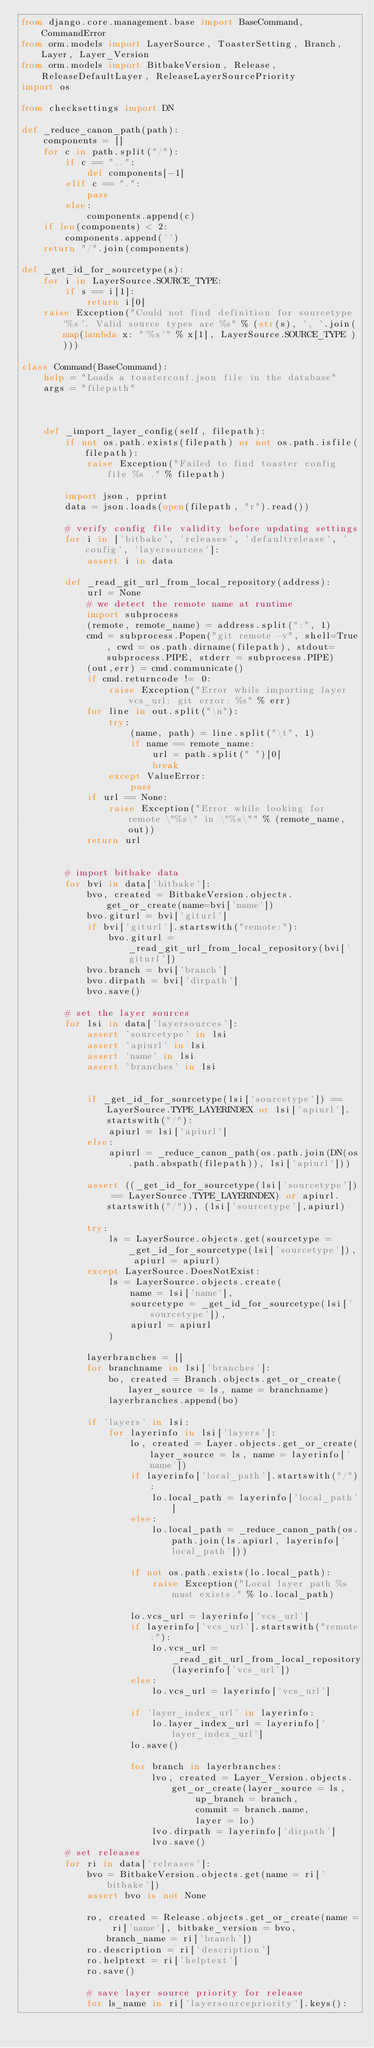Convert code to text. <code><loc_0><loc_0><loc_500><loc_500><_Python_>from django.core.management.base import BaseCommand, CommandError
from orm.models import LayerSource, ToasterSetting, Branch, Layer, Layer_Version
from orm.models import BitbakeVersion, Release, ReleaseDefaultLayer, ReleaseLayerSourcePriority
import os

from checksettings import DN

def _reduce_canon_path(path):
    components = []
    for c in path.split("/"):
        if c == "..":
            del components[-1]
        elif c == ".":
            pass
        else:
            components.append(c)
    if len(components) < 2:
        components.append('')
    return "/".join(components)

def _get_id_for_sourcetype(s):
    for i in LayerSource.SOURCE_TYPE:
        if s == i[1]:
            return i[0]
    raise Exception("Could not find definition for sourcetype '%s'. Valid source types are %s" % (str(s), ', '.join(map(lambda x: "'%s'" % x[1], LayerSource.SOURCE_TYPE ))))

class Command(BaseCommand):
    help = "Loads a toasterconf.json file in the database"
    args = "filepath"



    def _import_layer_config(self, filepath):
        if not os.path.exists(filepath) or not os.path.isfile(filepath):
            raise Exception("Failed to find toaster config file %s ." % filepath)

        import json, pprint
        data = json.loads(open(filepath, "r").read())

        # verify config file validity before updating settings
        for i in ['bitbake', 'releases', 'defaultrelease', 'config', 'layersources']:
            assert i in data

        def _read_git_url_from_local_repository(address):
            url = None
            # we detect the remote name at runtime
            import subprocess
            (remote, remote_name) = address.split(":", 1)
            cmd = subprocess.Popen("git remote -v", shell=True, cwd = os.path.dirname(filepath), stdout=subprocess.PIPE, stderr = subprocess.PIPE)
            (out,err) = cmd.communicate()
            if cmd.returncode != 0:
                raise Exception("Error while importing layer vcs_url: git error: %s" % err)
            for line in out.split("\n"):
                try:
                    (name, path) = line.split("\t", 1)
                    if name == remote_name:
                        url = path.split(" ")[0]
                        break
                except ValueError:
                    pass
            if url == None:
                raise Exception("Error while looking for remote \"%s\" in \"%s\"" % (remote_name, out))
            return url


        # import bitbake data
        for bvi in data['bitbake']:
            bvo, created = BitbakeVersion.objects.get_or_create(name=bvi['name'])
            bvo.giturl = bvi['giturl']
            if bvi['giturl'].startswith("remote:"):
                bvo.giturl = _read_git_url_from_local_repository(bvi['giturl'])
            bvo.branch = bvi['branch']
            bvo.dirpath = bvi['dirpath']
            bvo.save()

        # set the layer sources
        for lsi in data['layersources']:
            assert 'sourcetype' in lsi
            assert 'apiurl' in lsi
            assert 'name' in lsi
            assert 'branches' in lsi


            if _get_id_for_sourcetype(lsi['sourcetype']) == LayerSource.TYPE_LAYERINDEX or lsi['apiurl'].startswith("/"):
                apiurl = lsi['apiurl']
            else:
                apiurl = _reduce_canon_path(os.path.join(DN(os.path.abspath(filepath)), lsi['apiurl']))

            assert ((_get_id_for_sourcetype(lsi['sourcetype']) == LayerSource.TYPE_LAYERINDEX) or apiurl.startswith("/")), (lsi['sourcetype'],apiurl)

            try:
                ls = LayerSource.objects.get(sourcetype = _get_id_for_sourcetype(lsi['sourcetype']), apiurl = apiurl)
            except LayerSource.DoesNotExist:
                ls = LayerSource.objects.create(
                    name = lsi['name'],
                    sourcetype = _get_id_for_sourcetype(lsi['sourcetype']),
                    apiurl = apiurl
                )

            layerbranches = []
            for branchname in lsi['branches']:
                bo, created = Branch.objects.get_or_create(layer_source = ls, name = branchname)
                layerbranches.append(bo)

            if 'layers' in lsi:
                for layerinfo in lsi['layers']:
                    lo, created = Layer.objects.get_or_create(layer_source = ls, name = layerinfo['name'])
                    if layerinfo['local_path'].startswith("/"):
                        lo.local_path = layerinfo['local_path']
                    else:
                        lo.local_path = _reduce_canon_path(os.path.join(ls.apiurl, layerinfo['local_path']))

                    if not os.path.exists(lo.local_path):
                        raise Exception("Local layer path %s must exists." % lo.local_path)

                    lo.vcs_url = layerinfo['vcs_url']
                    if layerinfo['vcs_url'].startswith("remote:"):
                        lo.vcs_url = _read_git_url_from_local_repository(layerinfo['vcs_url'])
                    else:
                        lo.vcs_url = layerinfo['vcs_url']

                    if 'layer_index_url' in layerinfo:
                        lo.layer_index_url = layerinfo['layer_index_url']
                    lo.save()

                    for branch in layerbranches:
                        lvo, created = Layer_Version.objects.get_or_create(layer_source = ls,
                                up_branch = branch,
                                commit = branch.name,
                                layer = lo)
                        lvo.dirpath = layerinfo['dirpath']
                        lvo.save()
        # set releases
        for ri in data['releases']:
            bvo = BitbakeVersion.objects.get(name = ri['bitbake'])
            assert bvo is not None

            ro, created = Release.objects.get_or_create(name = ri['name'], bitbake_version = bvo, branch_name = ri['branch'])
            ro.description = ri['description']
            ro.helptext = ri['helptext']
            ro.save()

            # save layer source priority for release
            for ls_name in ri['layersourcepriority'].keys():</code> 